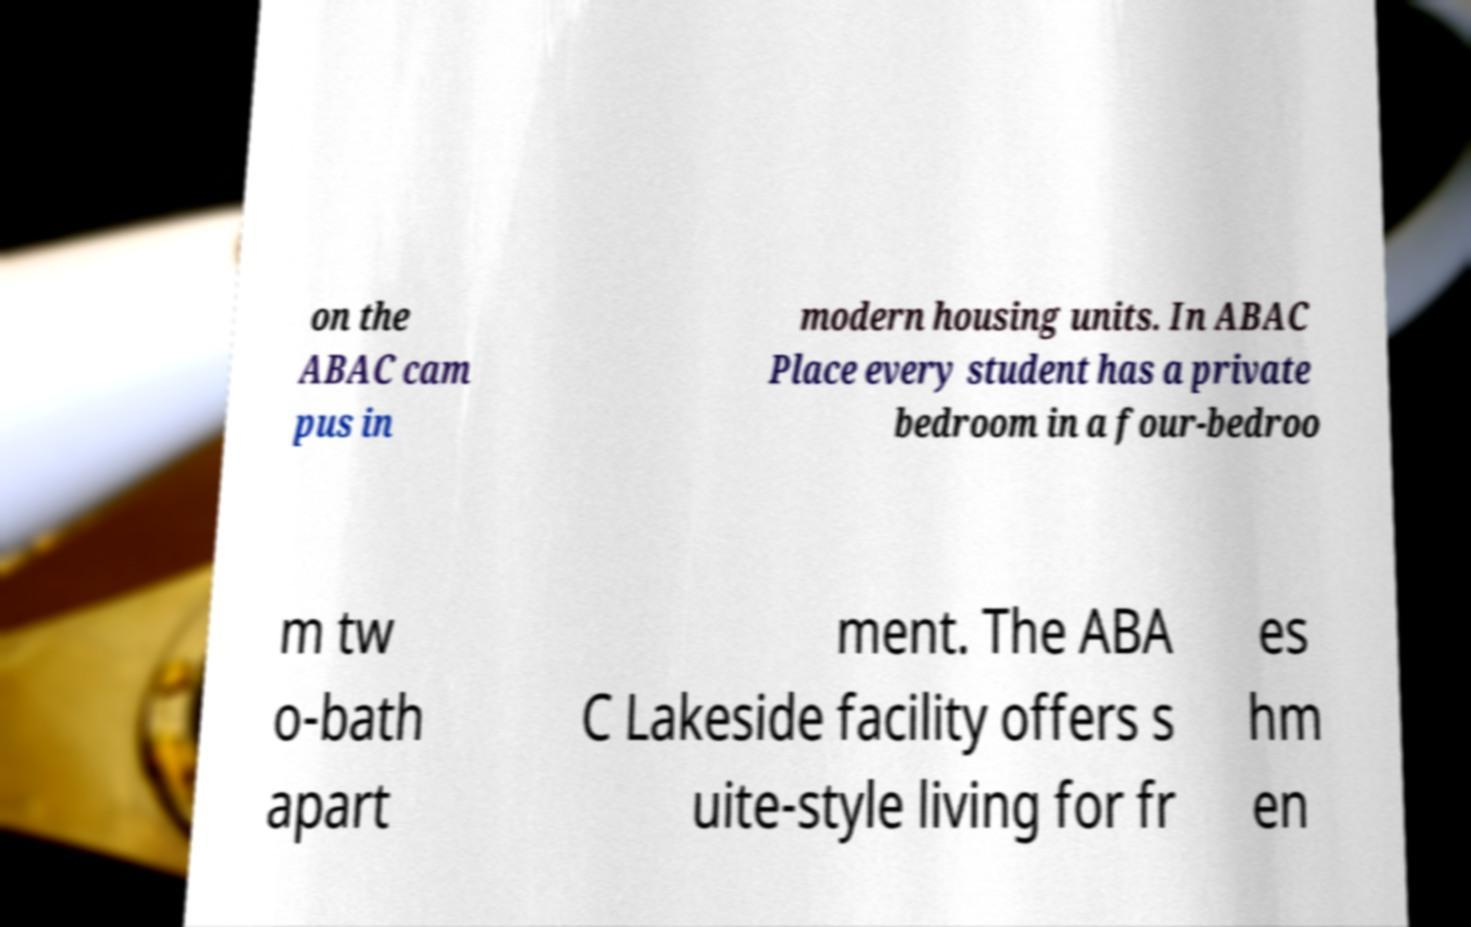Can you accurately transcribe the text from the provided image for me? on the ABAC cam pus in modern housing units. In ABAC Place every student has a private bedroom in a four-bedroo m tw o-bath apart ment. The ABA C Lakeside facility offers s uite-style living for fr es hm en 